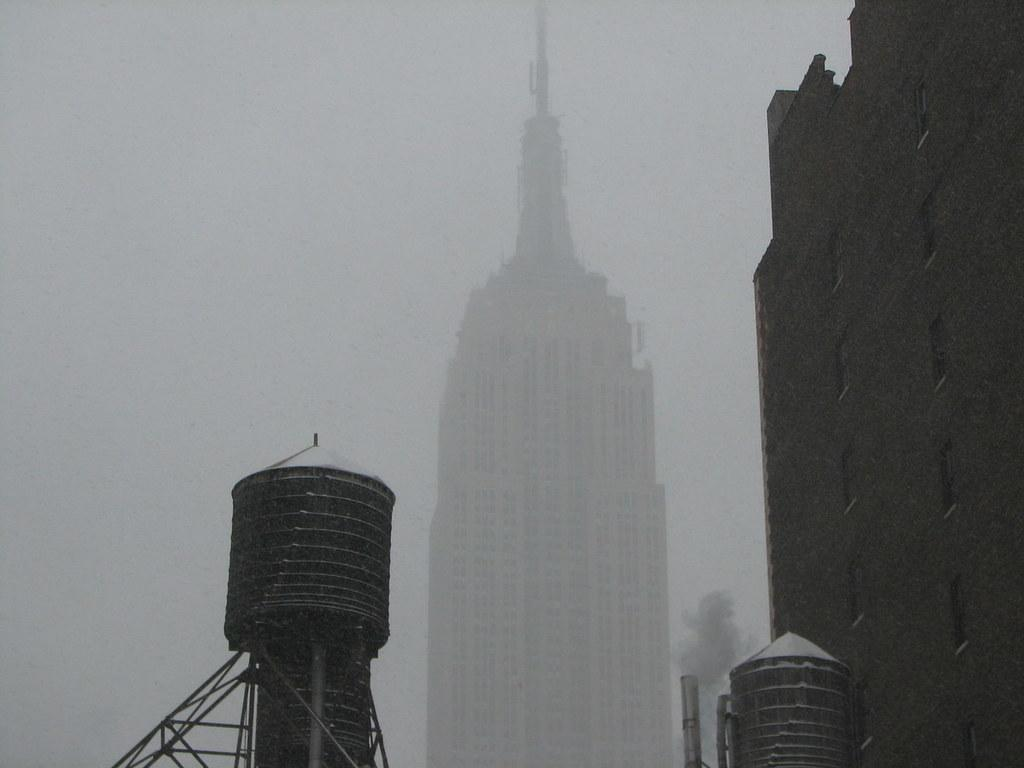What is the color scheme of the image? The image is black and white. What type of structures can be seen in the image? There are buildings in the image. What other objects are present in the image besides buildings? There are water tankers in the image. Can you see anyone smiling in the image? There is no indication of people or faces in the image, so it's not possible to determine if anyone is smiling. 